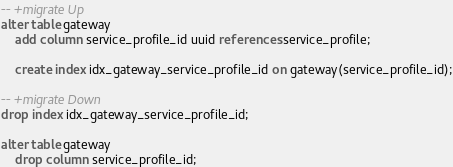Convert code to text. <code><loc_0><loc_0><loc_500><loc_500><_SQL_>-- +migrate Up
alter table gateway
    add column service_profile_id uuid references service_profile;

    create index idx_gateway_service_profile_id on gateway(service_profile_id);

-- +migrate Down
drop index idx_gateway_service_profile_id;

alter table gateway
    drop column service_profile_id;
</code> 